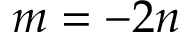Convert formula to latex. <formula><loc_0><loc_0><loc_500><loc_500>m = - 2 n</formula> 